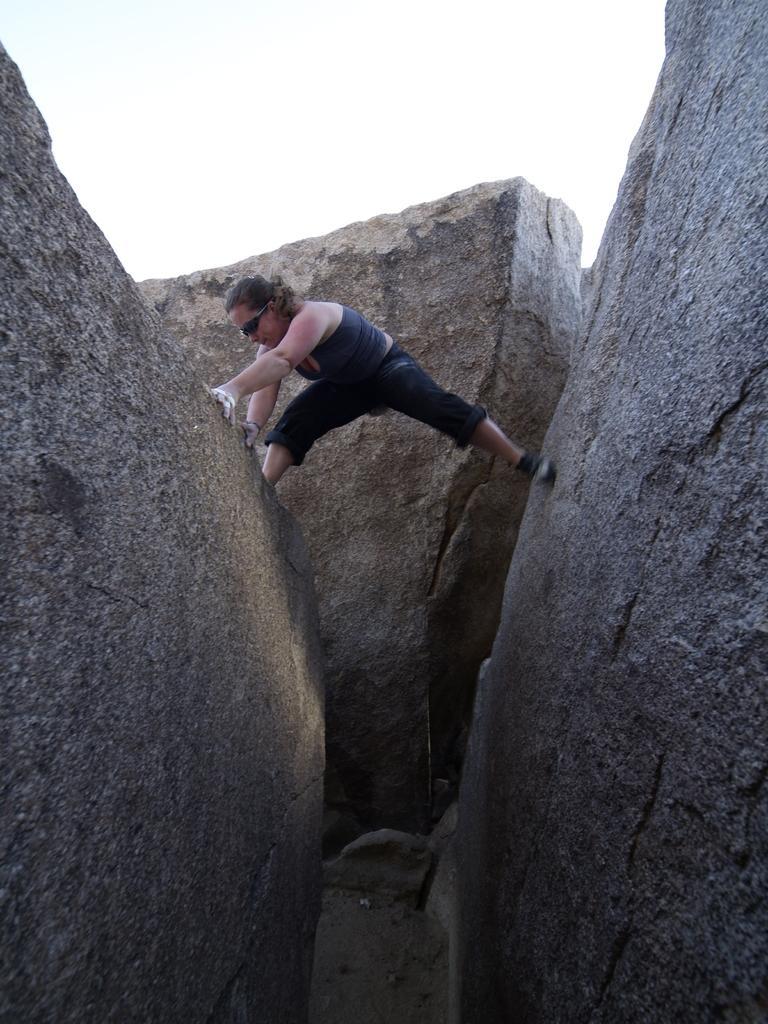How would you summarize this image in a sentence or two? In the picture we can see a two huge rock and a person is keeping leg on the one rock and another on the other rock and behind her we can see another rock and sky behind it. 